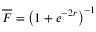Convert formula to latex. <formula><loc_0><loc_0><loc_500><loc_500>\overline { F } = \left ( 1 + e ^ { - 2 r } \right ) ^ { - 1 }</formula> 